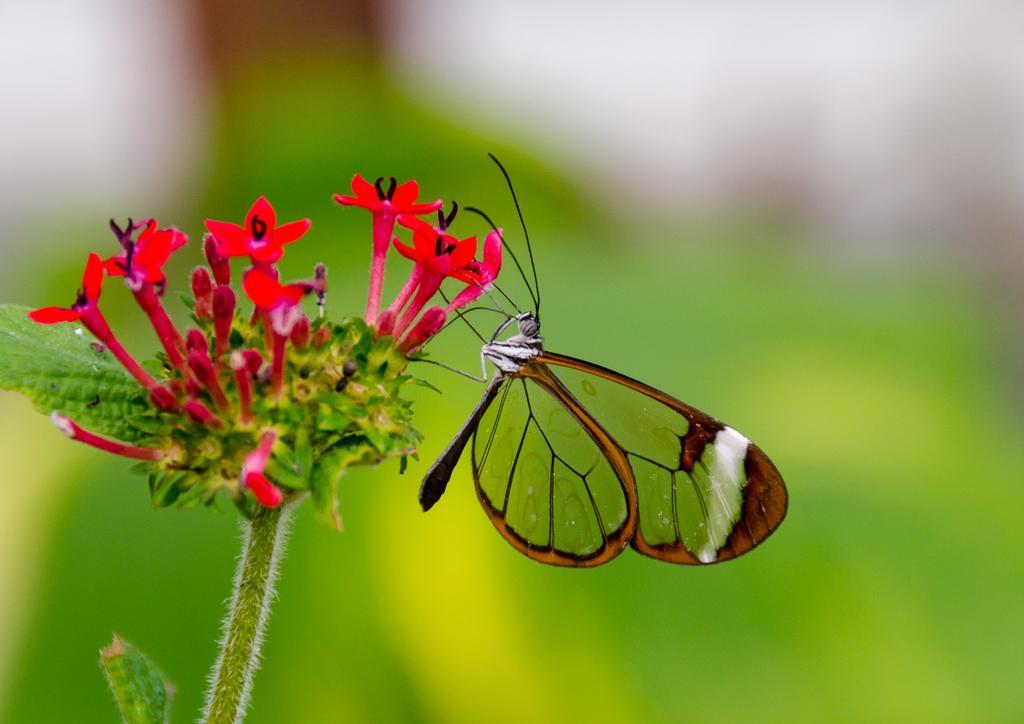Can you describe this image briefly? In the center of the image we can see leaves and flower, which is in red color. and we can see one butterfly on the flower. 